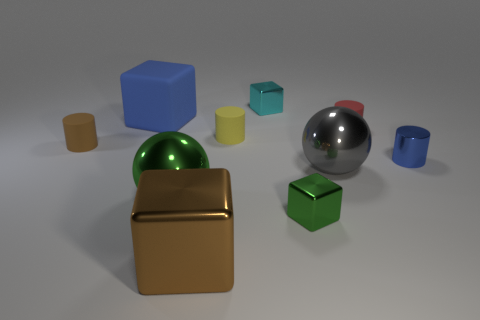There is a tiny thing that is left of the large brown object; what is it made of?
Provide a succinct answer. Rubber. How big is the blue object left of the blue thing that is right of the object behind the blue rubber thing?
Offer a very short reply. Large. Are the big block that is on the left side of the big brown metal block and the brown object that is to the left of the large green metal ball made of the same material?
Offer a terse response. Yes. What number of other objects are there of the same color as the big rubber thing?
Make the answer very short. 1. What number of objects are rubber cylinders left of the small yellow matte thing or blocks that are behind the small brown thing?
Give a very brief answer. 3. What is the size of the green object to the left of the small cube that is in front of the metallic cylinder?
Your response must be concise. Large. The gray metallic thing is what size?
Your answer should be very brief. Large. Do the tiny metal thing in front of the green ball and the sphere that is on the left side of the brown metallic object have the same color?
Provide a short and direct response. Yes. What number of other objects are there of the same material as the small green thing?
Keep it short and to the point. 5. Is there a tiny cyan metal thing?
Make the answer very short. Yes. 